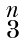Convert formula to latex. <formula><loc_0><loc_0><loc_500><loc_500>\begin{smallmatrix} n \\ 3 \end{smallmatrix}</formula> 